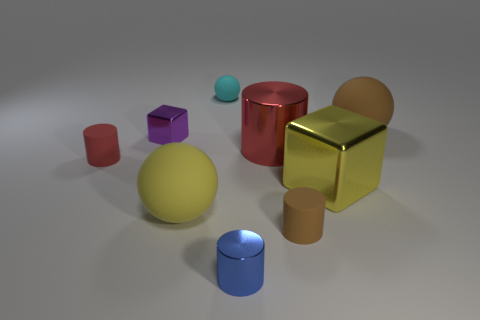How many other things are there of the same color as the big cylinder?
Your answer should be compact. 1. Is there a brown metallic object that has the same size as the red matte thing?
Make the answer very short. No. How big is the yellow object that is to the left of the yellow metallic cube?
Your answer should be compact. Large. What size is the red metal cylinder?
Offer a terse response. Large. What number of cubes are either tiny green shiny things or small brown matte things?
Keep it short and to the point. 0. There is a red cylinder that is the same material as the tiny cyan ball; what size is it?
Provide a short and direct response. Small. What number of matte spheres are the same color as the large block?
Offer a terse response. 1. There is a tiny blue cylinder; are there any large balls in front of it?
Give a very brief answer. No. There is a tiny cyan object; does it have the same shape as the small thing on the right side of the tiny blue cylinder?
Provide a short and direct response. No. What number of objects are brown spheres that are behind the yellow metal block or purple shiny things?
Offer a very short reply. 2. 